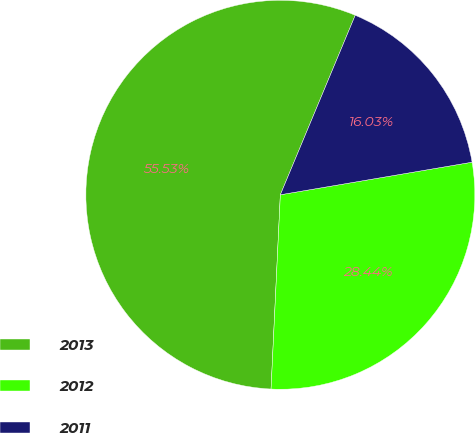<chart> <loc_0><loc_0><loc_500><loc_500><pie_chart><fcel>2013<fcel>2012<fcel>2011<nl><fcel>55.53%<fcel>28.44%<fcel>16.03%<nl></chart> 